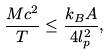<formula> <loc_0><loc_0><loc_500><loc_500>\frac { M c ^ { 2 } } { T } \leq \frac { k _ { B } A } { 4 l _ { p } ^ { 2 } } ,</formula> 